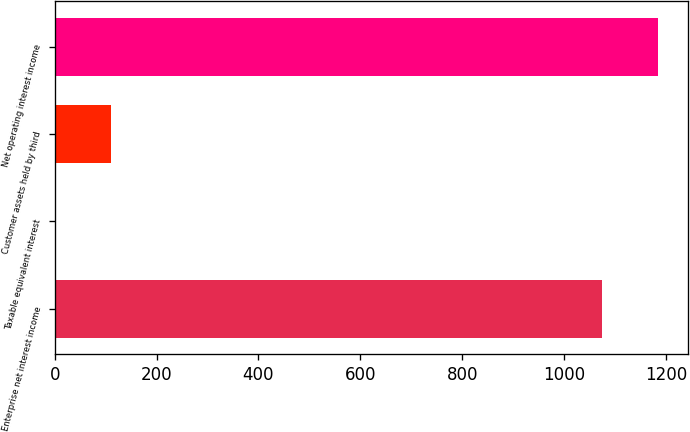Convert chart to OTSL. <chart><loc_0><loc_0><loc_500><loc_500><bar_chart><fcel>Enterprise net interest income<fcel>Taxable equivalent interest<fcel>Customer assets held by third<fcel>Net operating interest income<nl><fcel>1075<fcel>1<fcel>109.7<fcel>1183.7<nl></chart> 